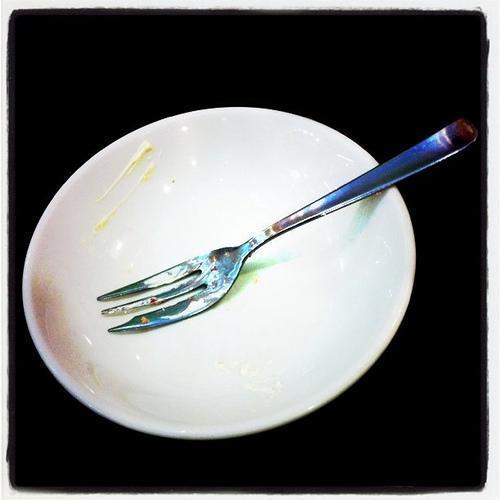How many forks are in the photo?
Give a very brief answer. 1. 